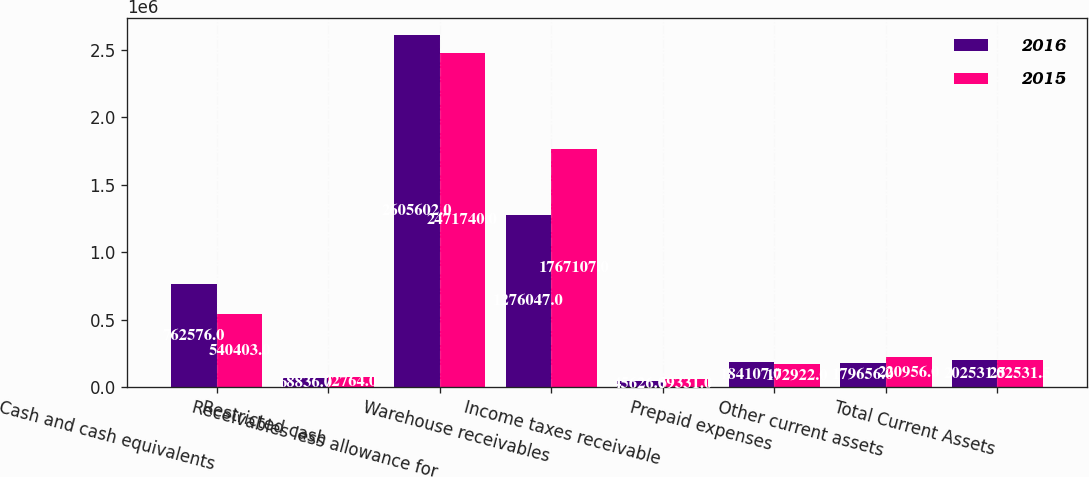Convert chart to OTSL. <chart><loc_0><loc_0><loc_500><loc_500><stacked_bar_chart><ecel><fcel>Cash and cash equivalents<fcel>Restricted cash<fcel>Receivables less allowance for<fcel>Warehouse receivables<fcel>Income taxes receivable<fcel>Prepaid expenses<fcel>Other current assets<fcel>Total Current Assets<nl><fcel>2016<fcel>762576<fcel>68836<fcel>2.6056e+06<fcel>1.27605e+06<fcel>45626<fcel>184107<fcel>179656<fcel>202532<nl><fcel>2015<fcel>540403<fcel>72764<fcel>2.47174e+06<fcel>1.76711e+06<fcel>59331<fcel>172922<fcel>220956<fcel>202532<nl></chart> 